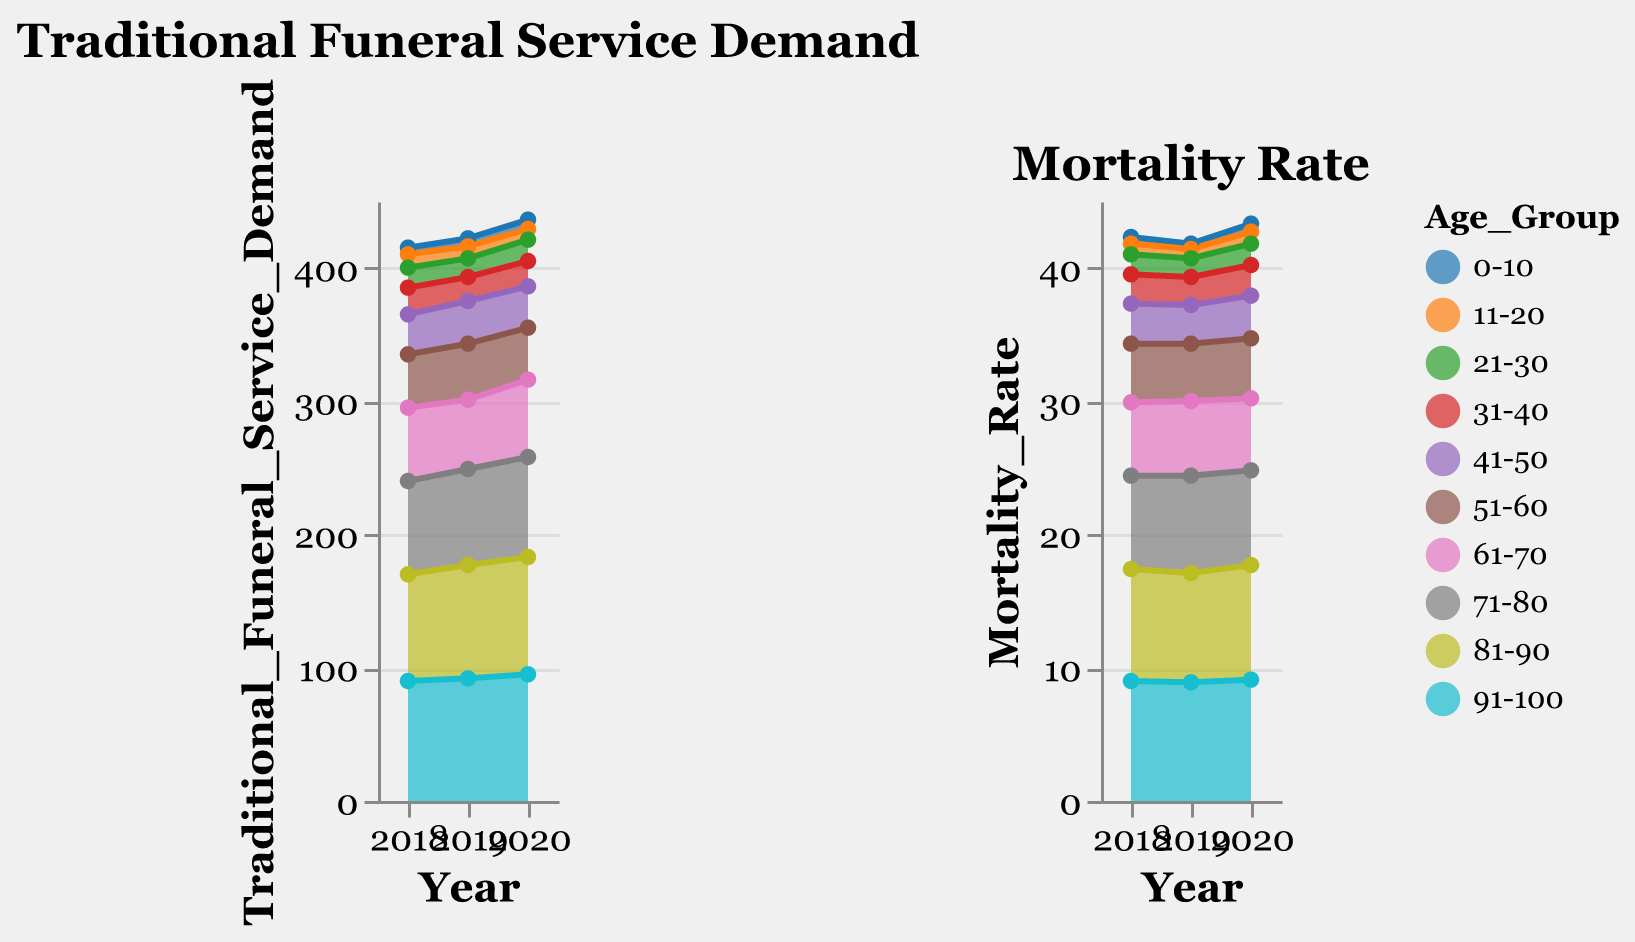What is the title of the first subplot? The title of the first subplot can be found at the top of the first area chart.
Answer: Traditional Funeral Service Demand What is the mortality rate for the age group 51-60 in 2018? To find this, look for the year 2018 and the age group 51-60 in the Mortality Rate subplot.
Answer: 4.4 Which age group had the highest Traditional Funeral Service Demand in 2020? To determine this, check the highest value on the y-axis in the Traditional Funeral Service Demand subplot for the year 2020.
Answer: 91-100 How did the Traditional Funeral Service Demand for the age group 41-50 change from 2019 to 2020? Look at the values for the age group 41-50 for the years 2019 and 2020 in the Traditional Funeral Service Demand subplot and calculate the difference.
Answer: Decreased by 1 Which age group had the lowest Mortality Rate in 2019? To find this, look for the lowest value on the y-axis in the Mortality Rate subplot for the year 2019.
Answer: 0-10 Between which years did the age group 81-90 see an increase in Traditional Funeral Service Demand? Check the Traditional Funeral Service Demand values for the age group 81-90 and observe the changes across the years.
Answer: 2018 to 2019 and 2019 to 2020 What was the trend in Mortality Rate for the age group 21-30 from 2018 to 2020? Observe the Mortality Rate values for the age group 21-30 over the years 2018, 2019, and 2020 and describe the pattern.
Answer: Increasing By how much did the Traditional Funeral Service Demand for age group 61-70 change from 2018 to 2020? Calculate the change by finding the difference in values for the age group 61-70 between 2018 and 2020 in the Traditional Funeral Service Demand subplot.
Answer: Increased by 3 In which year did the age group 31-40 see the highest Mortality Rate? Identify the peak value for the Mortality Rate for the age group 31-40 across the years 2018 to 2020.
Answer: 2020 